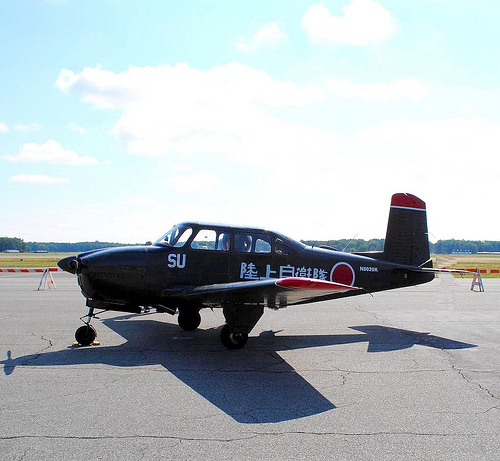What can you tell about the surrounding environment from the image? The environment appears to be an airfield or small airport, with wide-open spaces and runways designed for aircraft operations. In the distance, there is a horizon with trees, indicating it is located in a relatively open area with natural surroundings. Imagine this scene at night. What would it look like? At night, this scene would be transformed into a quiet, serene airfield beneath a star-speckled sky. The runway lights would cast a soft glow, illuminating the silhouette of the plane, with the calm night breeze gently rustling the trees on the horizon. Create a story involving this plane. During the Second World War, this humble aircraft played a pivotal role in training young pilots. Known affectionately as 'Blackbird', it guided countless aviators, now veterans, through their first flights. Under the endless blue sky and against the verdant backdrop of trees, it meticulously demonstrated maneuver after maneuver. Generations later, its tales are whispered among the winds, as young enthusiasts gather around it, hearing echoing stories of bravery and dreams that took flight from this very runway. 